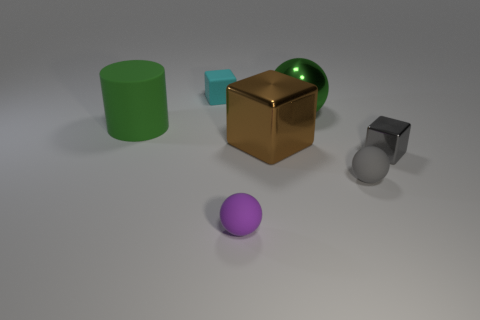Subtract all matte spheres. How many spheres are left? 1 Subtract all gray cylinders. How many purple spheres are left? 1 Add 3 small metallic cubes. How many objects exist? 10 Subtract all green balls. How many balls are left? 2 Subtract 2 cubes. How many cubes are left? 1 Add 6 big yellow matte cylinders. How many big yellow matte cylinders exist? 6 Subtract 0 red spheres. How many objects are left? 7 Subtract all blocks. How many objects are left? 4 Subtract all yellow blocks. Subtract all green balls. How many blocks are left? 3 Subtract all small gray rubber objects. Subtract all small purple things. How many objects are left? 5 